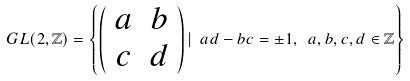Convert formula to latex. <formula><loc_0><loc_0><loc_500><loc_500>G L ( 2 , \mathbb { Z } ) = \left \{ \left ( \begin{array} { c c } a & b \\ c & d \\ \end{array} \right ) | \ a d - b c = \pm 1 , \ a , b , c , d \in \mathbb { Z } \right \}</formula> 